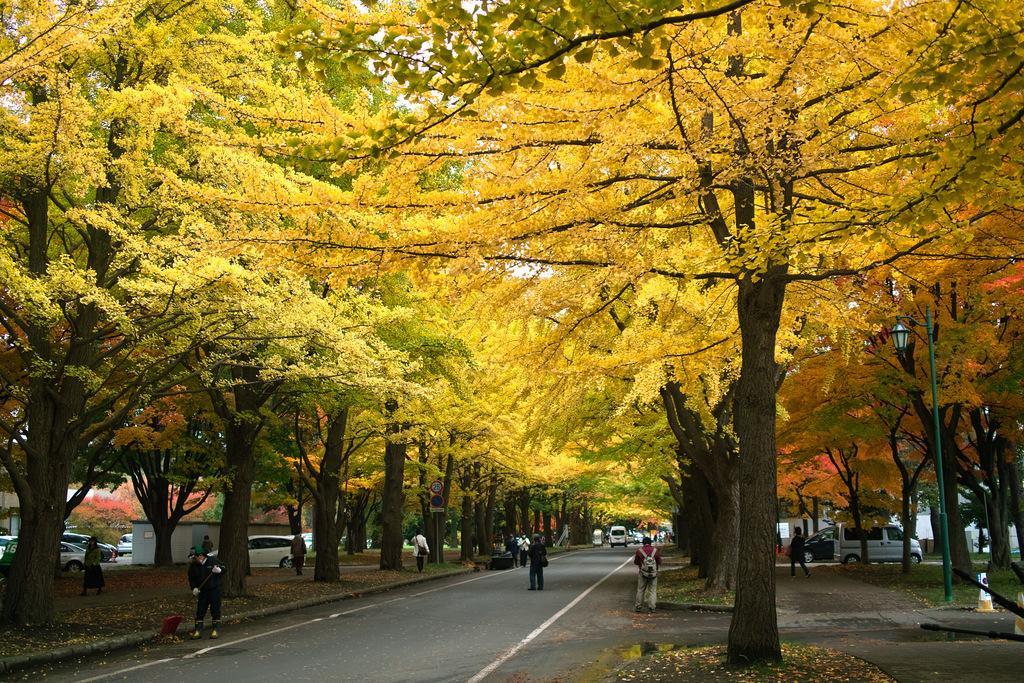In one or two sentences, can you explain what this image depicts? This is an outside view. At the bottom of the image there is a road. In the background, I can see few vehicles on the road. On both sides of the road there are many trees and few people are walking on the footpath. 